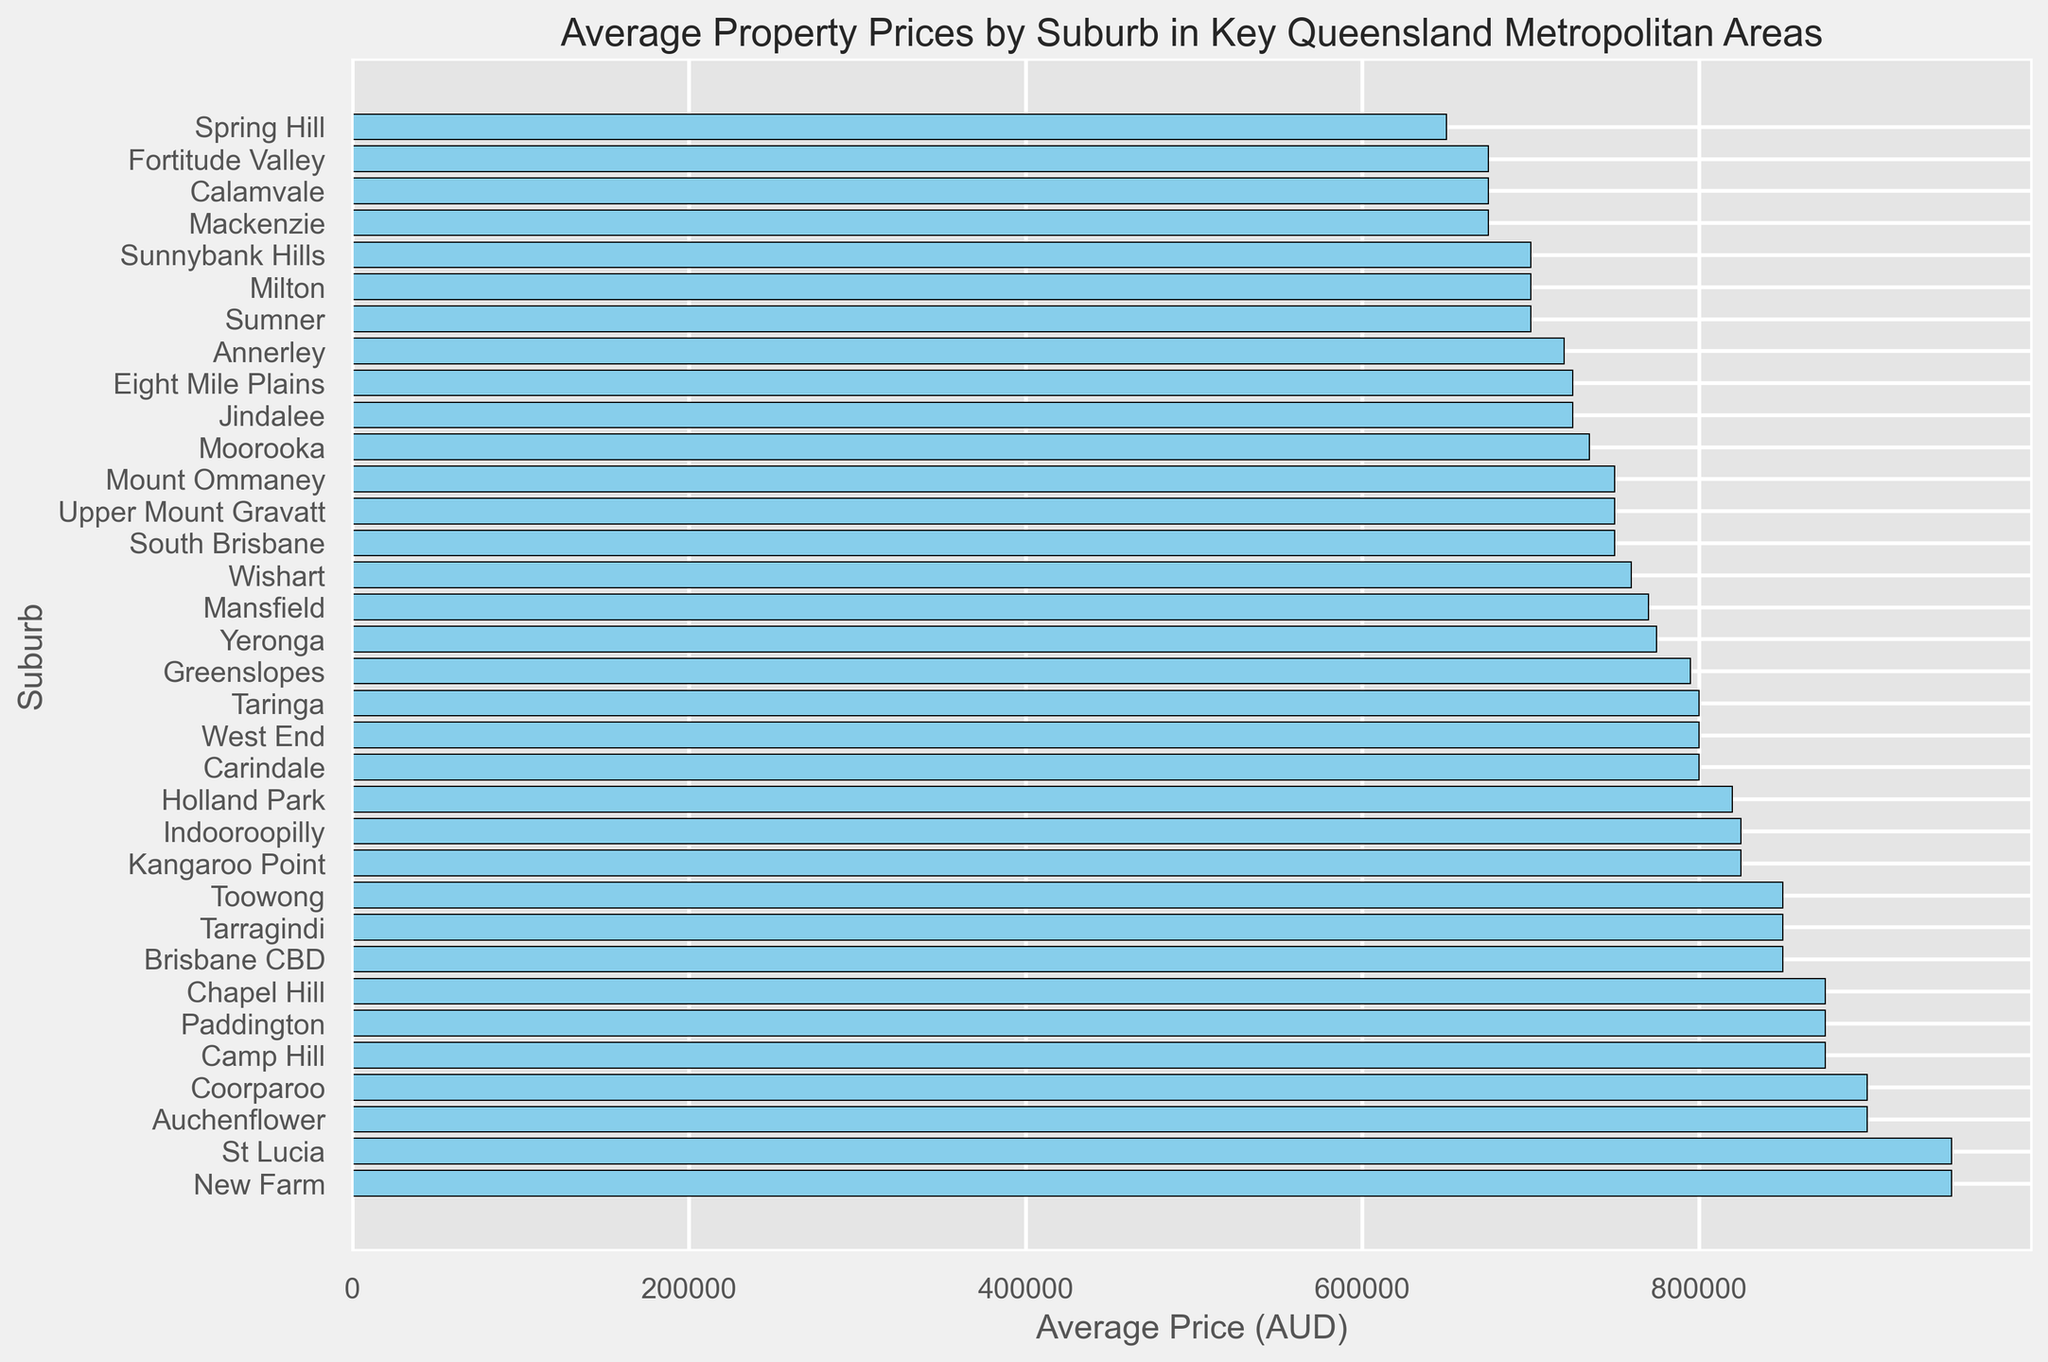What is the most expensive suburb based on average property prices? The data shows each suburb listed along with the bar chart representing their average property price. By visual inspection, the suburb with the longest bar (highest value) is the most expensive.
Answer: New Farm and St Lucia Which suburb has a higher average property price: West End or Carindale? By comparing the lengths of the bars for West End and Carindale, it's clear that the bar for Carindale is longer, indicating a higher average price.
Answer: Carindale How much higher is the average property price in Paddington compared to Jindalee? First, locate the bars for Paddington and Jindalee. Paddington's average price is 875,000 AUD, and Jindalee's is 725,000 AUD. Subtract Jindalee's price from Paddington's: 875,000 - 725,000 = 150,000 AUD.
Answer: 150,000 AUD What is the average property price difference between Kangaroo Point and South Brisbane? Kangaroo Point has an average price of 825,000 AUD, while South Brisbane's is 750,000 AUD. Subtract South Brisbane's price from Kangaroo Point's: 825,000 - 750,000 = 75,000 AUD.
Answer: 75,000 AUD Which suburb has the lowest average property price? By identifying the shortest bar on the chart, we can determine that the lowest average property price corresponds to that suburb.
Answer: Spring Hill What is the combined average property price for the Brisbane CBD, New Farm, and Paddington? Sum up the average property prices for Brisbane CBD (850,000 AUD), New Farm (950,000 AUD), and Paddington (875,000 AUD): 850,000 + 950,000 + 875,000 = 2,675,000 AUD.
Answer: 2,675,000 AUD Is the average price in Coorparoo higher than in Indooroopilly? To determine this, compare the lengths of the bars for Coorparoo and Indooroopilly. Since the bar for Coorparoo is longer, it has a higher average property price.
Answer: Yes Among Fortitude Valley, Milton, and Calamvale, which suburb has the highest average property price? By checking the lengths of the bars for Fortitude Valley (675,000 AUD), Milton (700,000 AUD), and Calamvale (675,000 AUD), Milton has the longest bar and thus, the highest average price.
Answer: Milton Which suburb falls exactly in the middle if you list the suburbs by average property price from lowest to highest? The data should be sorted to find the median. With 34 suburbs, the median falls between the 17th and 18th values. The median suburbs in the sorted list are Upper Mount Gravatt and Mount Ommaney.
Answer: Upper Mount Gravatt and Mount Ommaney 